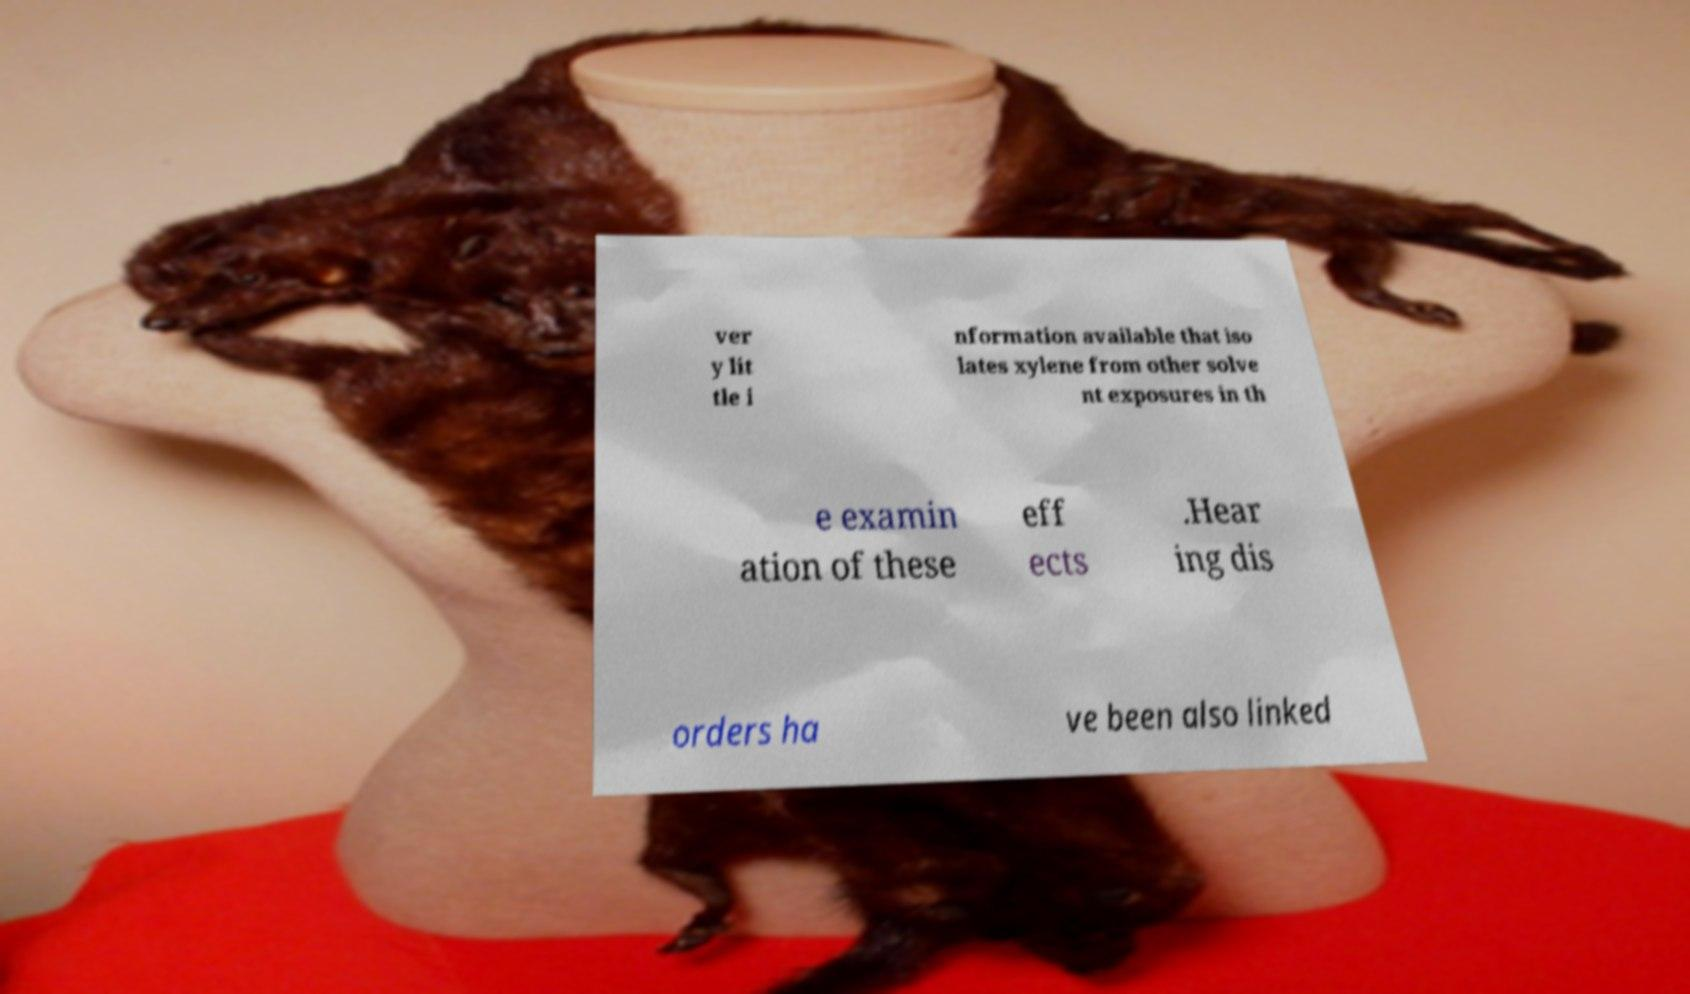Can you read and provide the text displayed in the image?This photo seems to have some interesting text. Can you extract and type it out for me? ver y lit tle i nformation available that iso lates xylene from other solve nt exposures in th e examin ation of these eff ects .Hear ing dis orders ha ve been also linked 